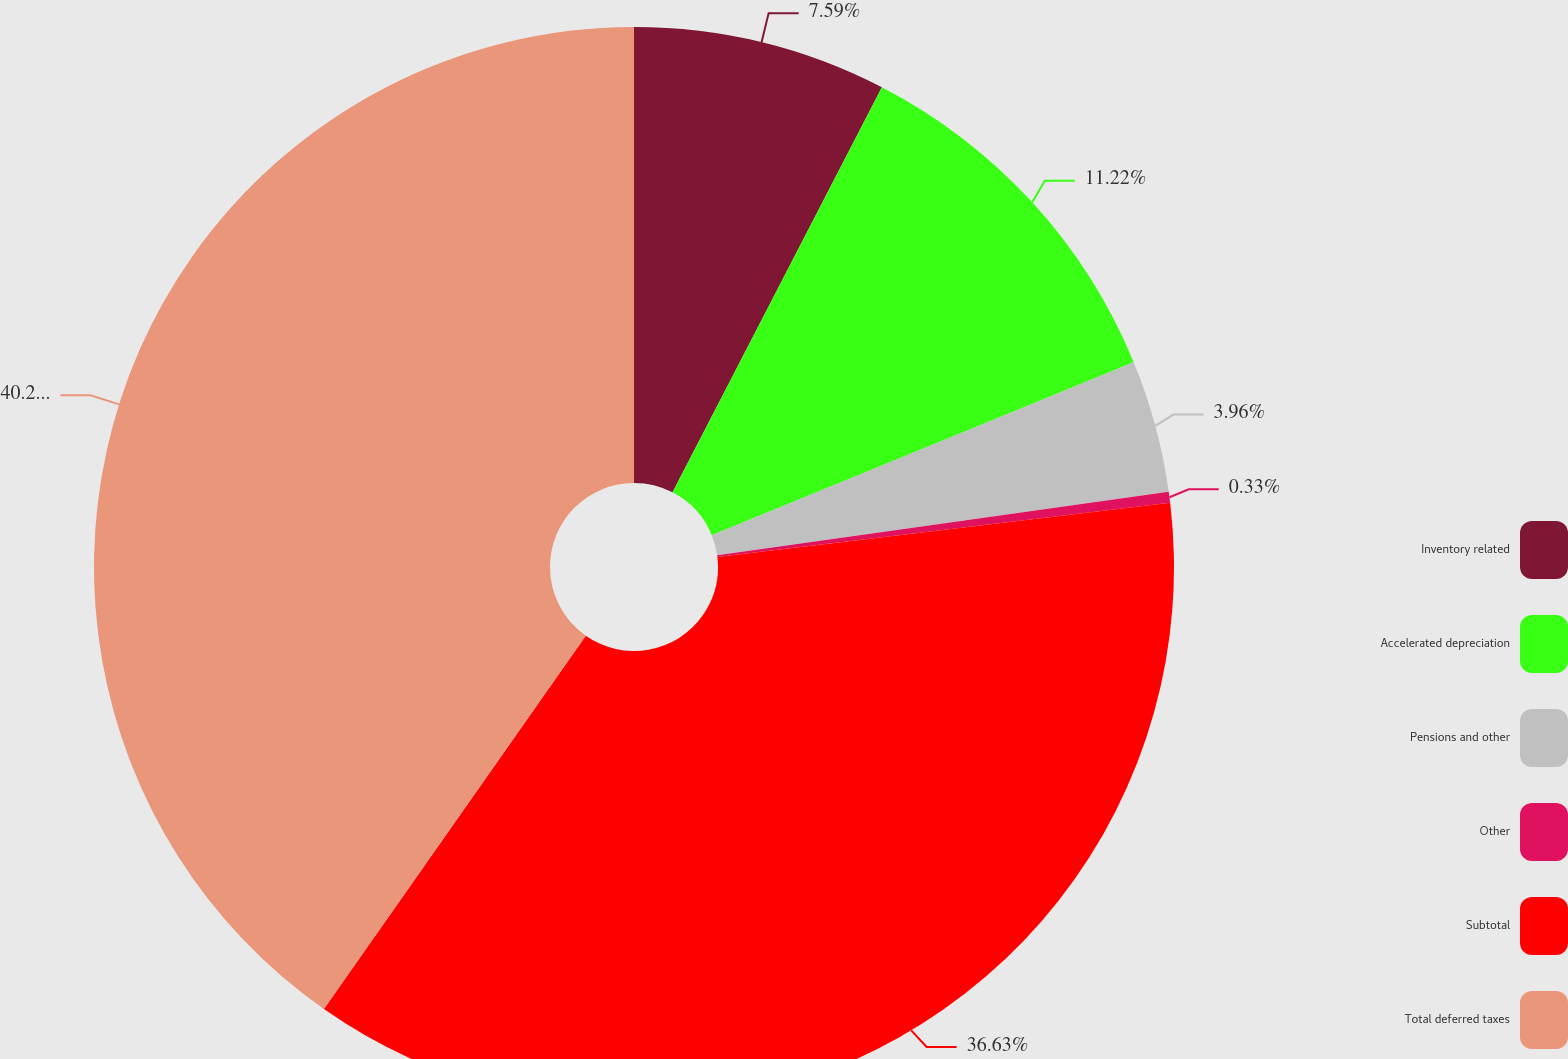Convert chart to OTSL. <chart><loc_0><loc_0><loc_500><loc_500><pie_chart><fcel>Inventory related<fcel>Accelerated depreciation<fcel>Pensions and other<fcel>Other<fcel>Subtotal<fcel>Total deferred taxes<nl><fcel>7.59%<fcel>11.22%<fcel>3.96%<fcel>0.33%<fcel>36.63%<fcel>40.26%<nl></chart> 